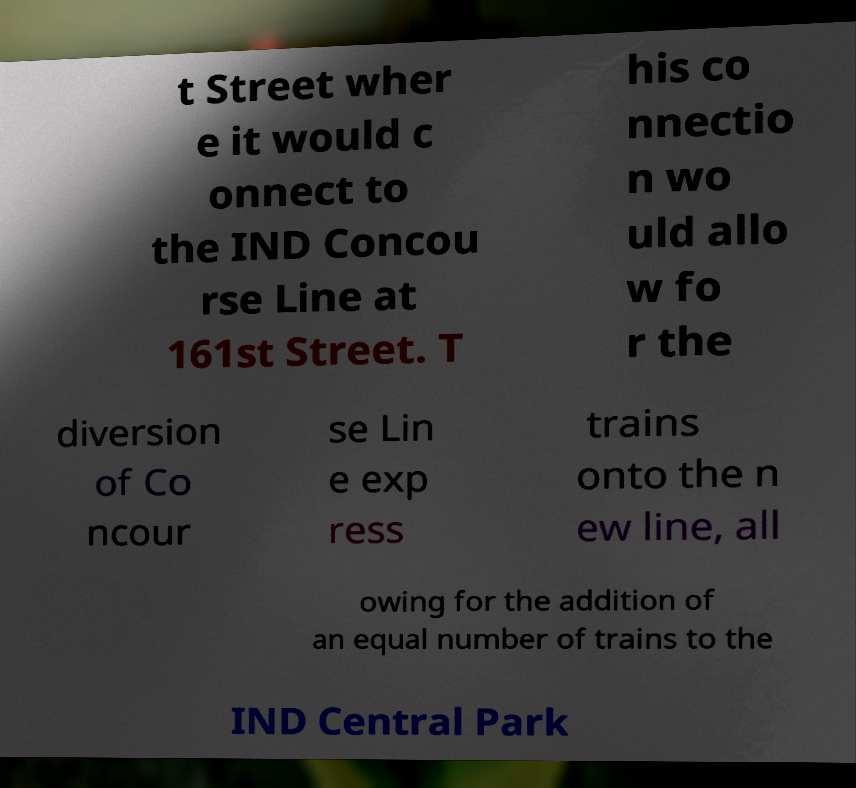For documentation purposes, I need the text within this image transcribed. Could you provide that? t Street wher e it would c onnect to the IND Concou rse Line at 161st Street. T his co nnectio n wo uld allo w fo r the diversion of Co ncour se Lin e exp ress trains onto the n ew line, all owing for the addition of an equal number of trains to the IND Central Park 